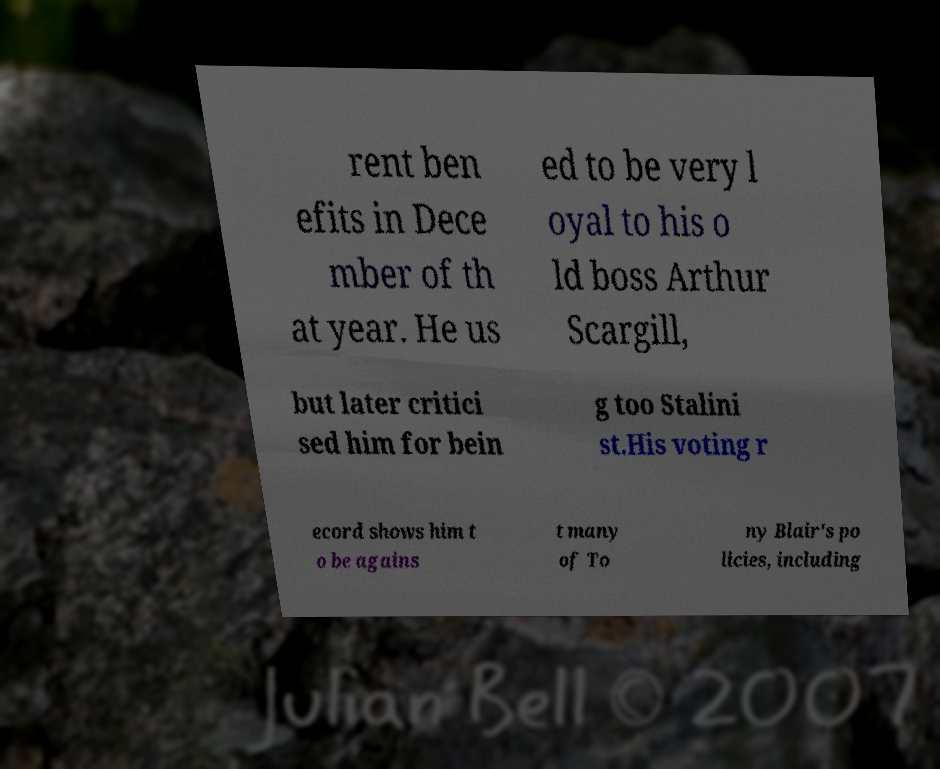Can you read and provide the text displayed in the image?This photo seems to have some interesting text. Can you extract and type it out for me? rent ben efits in Dece mber of th at year. He us ed to be very l oyal to his o ld boss Arthur Scargill, but later critici sed him for bein g too Stalini st.His voting r ecord shows him t o be agains t many of To ny Blair's po licies, including 